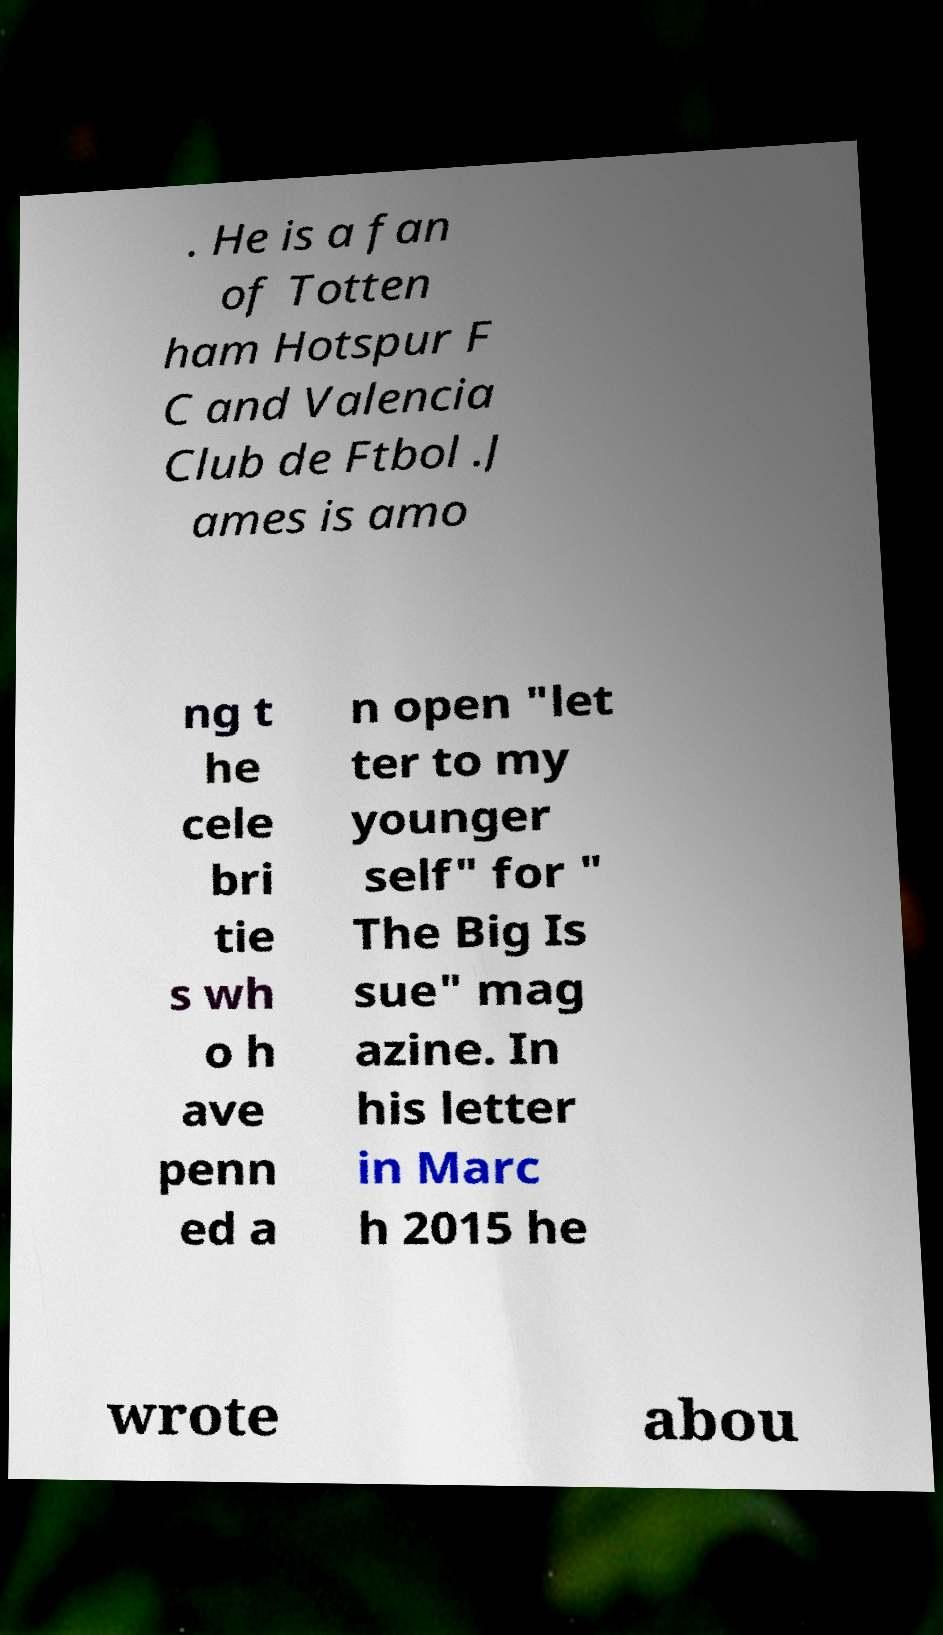For documentation purposes, I need the text within this image transcribed. Could you provide that? . He is a fan of Totten ham Hotspur F C and Valencia Club de Ftbol .J ames is amo ng t he cele bri tie s wh o h ave penn ed a n open "let ter to my younger self" for " The Big Is sue" mag azine. In his letter in Marc h 2015 he wrote abou 